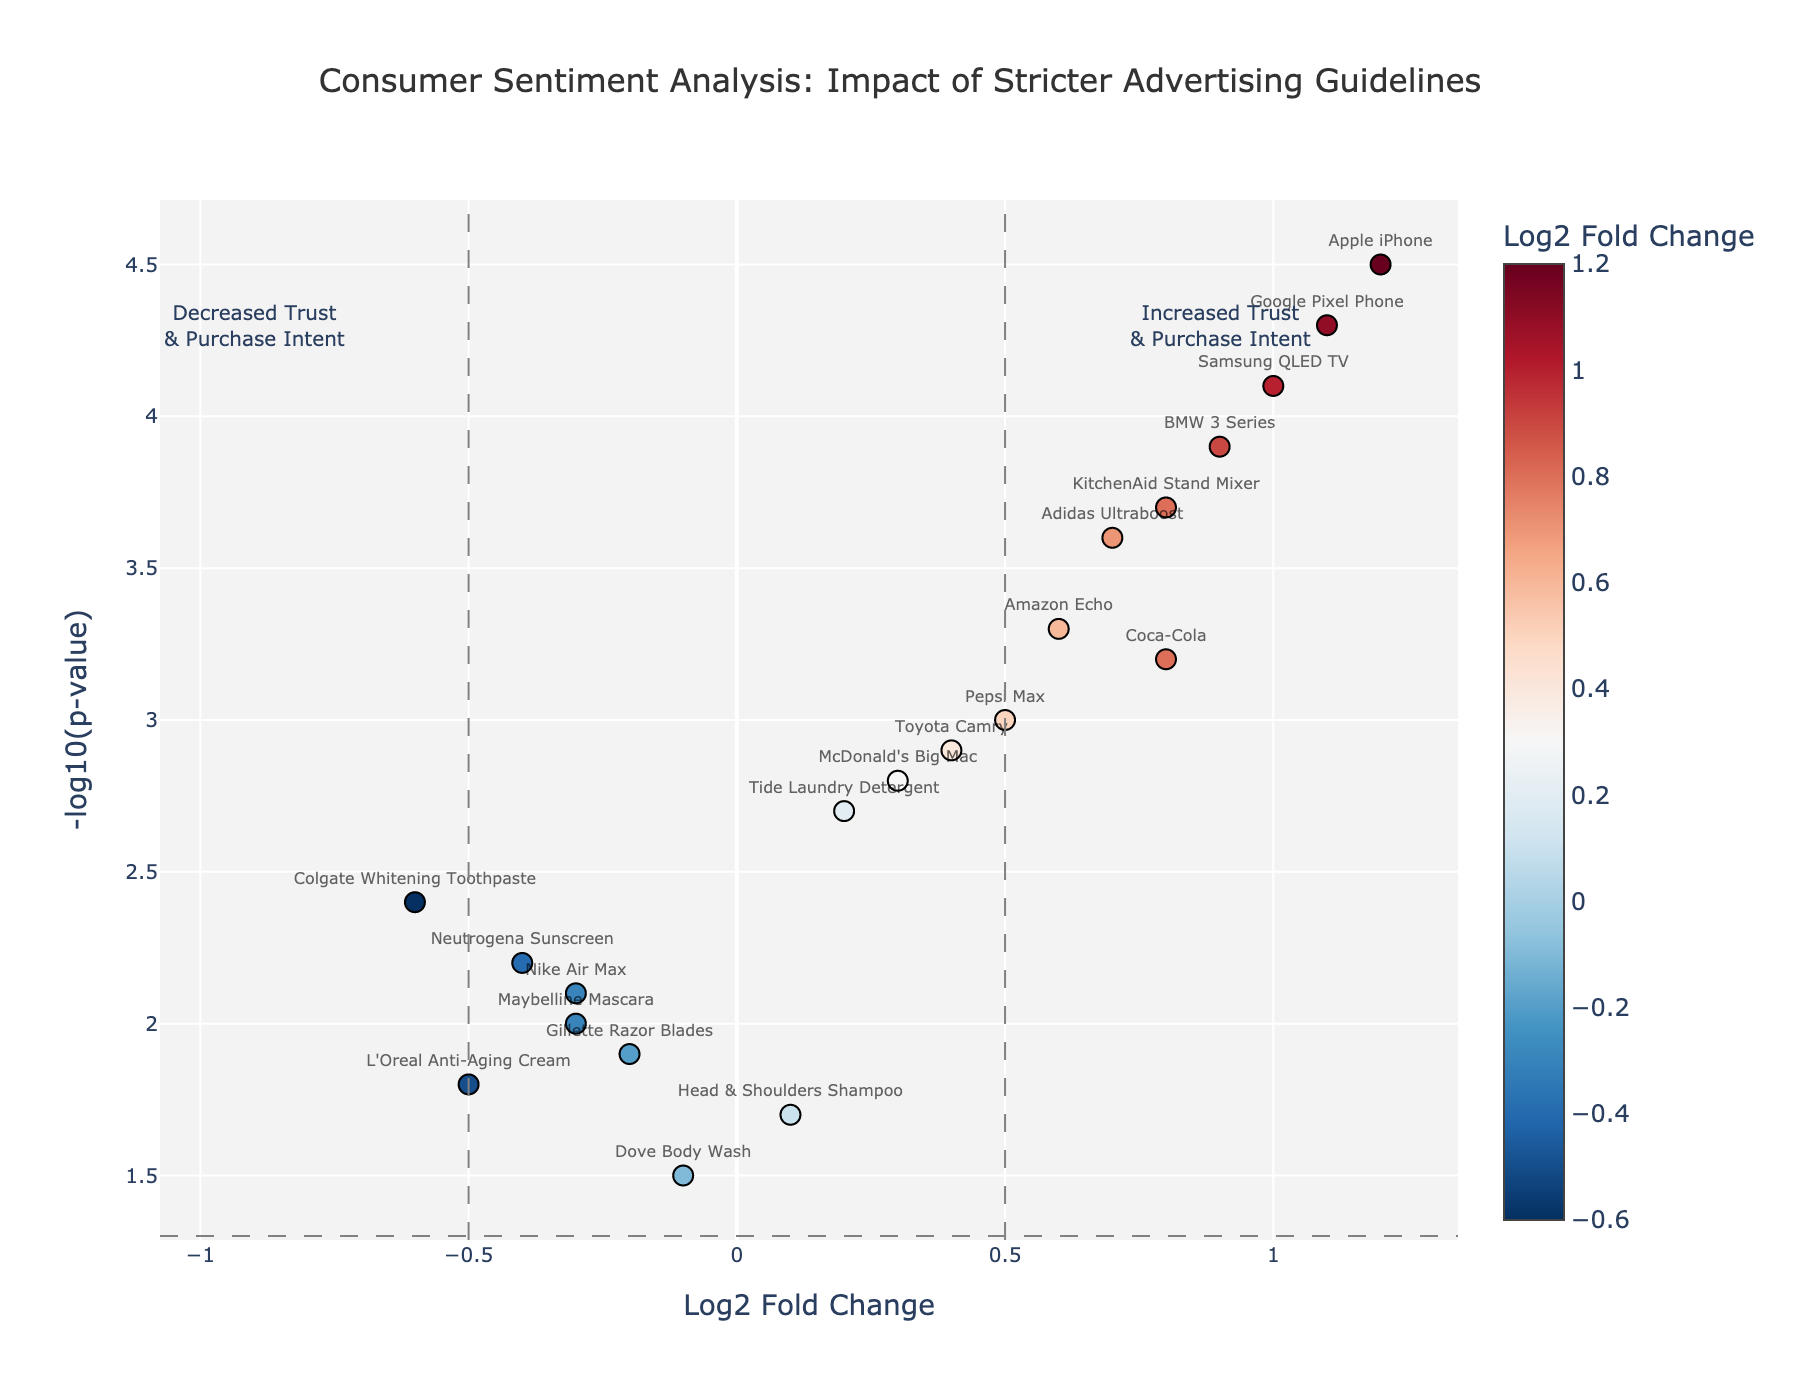What is the title of the plot? The title of the plot is usually displayed at the top of the figure.
Answer: Consumer Sentiment Analysis: Impact of Stricter Advertising Guidelines How many products have a positive Log2 Fold Change? Identify the data points to the right of the y-axis (Log2 Fold Change > 0).
Answer: 13 Which product shows the highest NegativeLogPValue? Look for the highest value on the y-axis.
Answer: Apple iPhone Compare the Log2 Fold Change of Coca-Cola and Google Pixel Phone. Which one is higher? Locate both data points and compare their x-axis values.
Answer: Google Pixel Phone Which product has the lowest -log10(p-value) with a negative Log2 Fold Change? Focus on data points with negative Log2 Fold Change and identify the lowest y-axis value.
Answer: Dove Body Wash What are the threshold values for significant fold change and p-value in this plot? Identify horizontal and vertical lines splitting the plot into quadrants.
Answer: Log2 Fold Change: ±0.5, P-value: -log10(0.05) Count how many products fall into the "Increased Trust & Purchase Intent" quadrant. Count data points in the upper-right quadrant (Log2 Fold Change > 0.5 and -log10(p-value) > -log10(0.05)).
Answer: 10 Identify one product with increased trust and relatively low purchase intent. Look for a product in the upper part of the plot but towards the center in x-axis with positive Log2 Fold Change.
Answer: Tide Laundry Detergent Which products stand out with significantly increased purchase intent after implementing stricter guidelines? Identify products with both high Log2 Fold Change and high NegativeLogPValue.
Answer: Apple iPhone, Samsung QLED TV Determine the average Log2 Fold Change for products with negative fold changes. Sum the Log2 Fold Change of all negative values and divide by the number of such data points. (-0.6 - 0.2 - 0.4 - 0.3 - 0.5 - 0.1) / 6 = -0.35
Answer: -0.35 